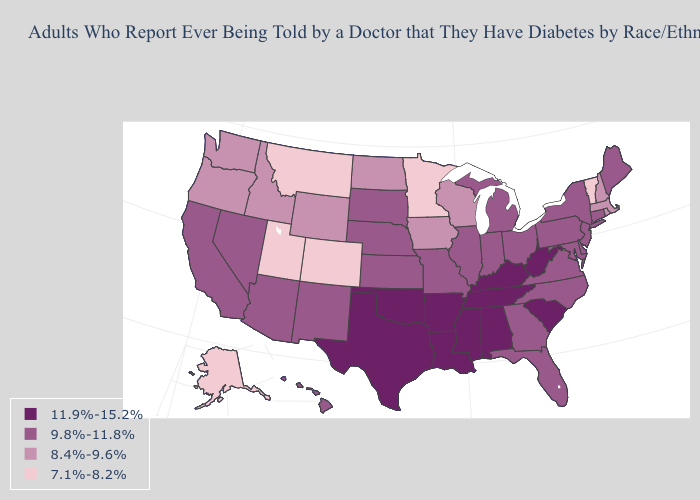Which states have the lowest value in the USA?
Be succinct. Alaska, Colorado, Minnesota, Montana, Utah, Vermont. Name the states that have a value in the range 7.1%-8.2%?
Quick response, please. Alaska, Colorado, Minnesota, Montana, Utah, Vermont. What is the highest value in the USA?
Give a very brief answer. 11.9%-15.2%. What is the lowest value in states that border Arizona?
Be succinct. 7.1%-8.2%. What is the value of Missouri?
Write a very short answer. 9.8%-11.8%. What is the value of New York?
Quick response, please. 9.8%-11.8%. What is the value of Kentucky?
Answer briefly. 11.9%-15.2%. Which states have the highest value in the USA?
Quick response, please. Alabama, Arkansas, Kentucky, Louisiana, Mississippi, Oklahoma, South Carolina, Tennessee, Texas, West Virginia. Is the legend a continuous bar?
Short answer required. No. Among the states that border Wisconsin , does Illinois have the highest value?
Quick response, please. Yes. Does Alabama have the highest value in the USA?
Concise answer only. Yes. What is the lowest value in states that border Tennessee?
Write a very short answer. 9.8%-11.8%. Name the states that have a value in the range 9.8%-11.8%?
Quick response, please. Arizona, California, Connecticut, Delaware, Florida, Georgia, Hawaii, Illinois, Indiana, Kansas, Maine, Maryland, Michigan, Missouri, Nebraska, Nevada, New Jersey, New Mexico, New York, North Carolina, Ohio, Pennsylvania, South Dakota, Virginia. Does Ohio have the lowest value in the MidWest?
Short answer required. No. What is the lowest value in the South?
Answer briefly. 9.8%-11.8%. 